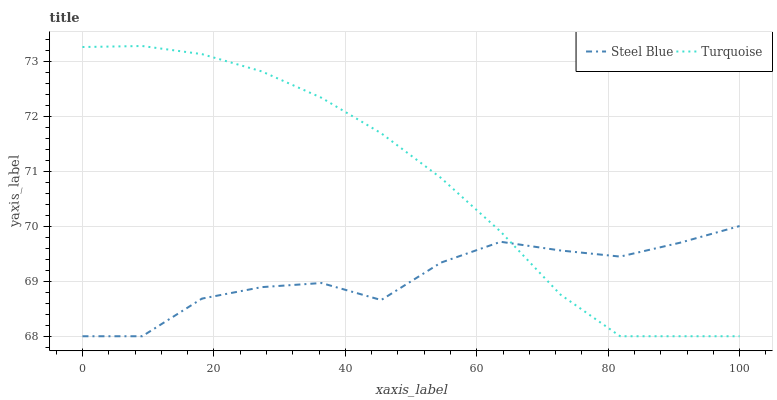Does Steel Blue have the minimum area under the curve?
Answer yes or no. Yes. Does Turquoise have the maximum area under the curve?
Answer yes or no. Yes. Does Steel Blue have the maximum area under the curve?
Answer yes or no. No. Is Turquoise the smoothest?
Answer yes or no. Yes. Is Steel Blue the roughest?
Answer yes or no. Yes. Is Steel Blue the smoothest?
Answer yes or no. No. Does Steel Blue have the highest value?
Answer yes or no. No. 